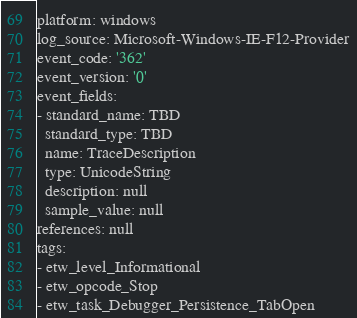Convert code to text. <code><loc_0><loc_0><loc_500><loc_500><_YAML_>platform: windows
log_source: Microsoft-Windows-IE-F12-Provider
event_code: '362'
event_version: '0'
event_fields:
- standard_name: TBD
  standard_type: TBD
  name: TraceDescription
  type: UnicodeString
  description: null
  sample_value: null
references: null
tags:
- etw_level_Informational
- etw_opcode_Stop
- etw_task_Debugger_Persistence_TabOpen
</code> 